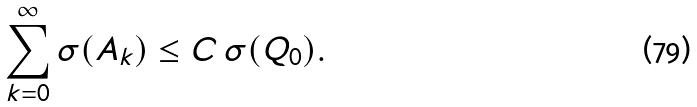Convert formula to latex. <formula><loc_0><loc_0><loc_500><loc_500>\sum _ { k = 0 } ^ { \infty } \sigma ( A _ { k } ) \leq C \, \sigma ( Q _ { 0 } ) .</formula> 